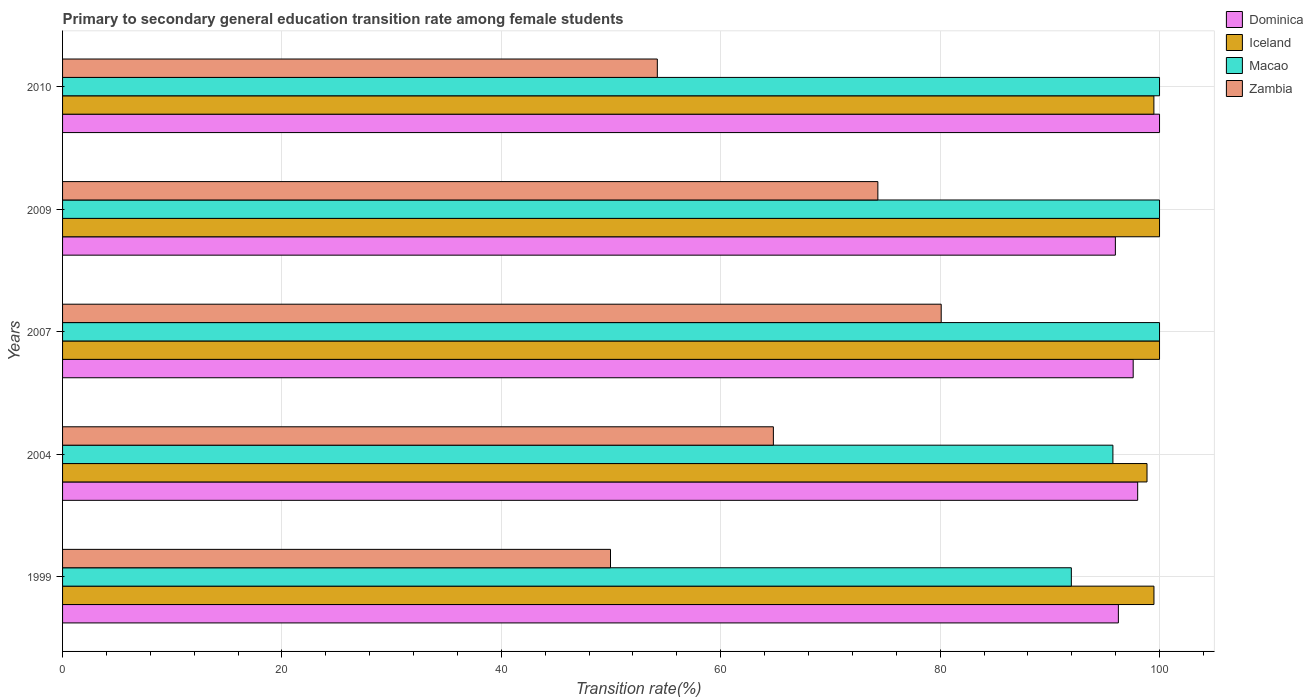Are the number of bars per tick equal to the number of legend labels?
Keep it short and to the point. Yes. Are the number of bars on each tick of the Y-axis equal?
Your answer should be compact. Yes. How many bars are there on the 5th tick from the bottom?
Provide a succinct answer. 4. What is the label of the 5th group of bars from the top?
Ensure brevity in your answer.  1999. In how many cases, is the number of bars for a given year not equal to the number of legend labels?
Ensure brevity in your answer.  0. Across all years, what is the maximum transition rate in Macao?
Offer a terse response. 100. Across all years, what is the minimum transition rate in Dominica?
Provide a succinct answer. 95.97. What is the total transition rate in Iceland in the graph?
Offer a very short reply. 497.83. What is the difference between the transition rate in Iceland in 1999 and that in 2010?
Give a very brief answer. 0.01. What is the difference between the transition rate in Dominica in 2010 and the transition rate in Macao in 1999?
Offer a very short reply. 8.04. What is the average transition rate in Zambia per year?
Make the answer very short. 64.68. What is the ratio of the transition rate in Iceland in 1999 to that in 2010?
Offer a very short reply. 1. Is the transition rate in Zambia in 1999 less than that in 2010?
Your answer should be very brief. Yes. What is the difference between the highest and the second highest transition rate in Zambia?
Your response must be concise. 5.77. What is the difference between the highest and the lowest transition rate in Macao?
Provide a short and direct response. 8.04. What does the 4th bar from the bottom in 2004 represents?
Offer a terse response. Zambia. How many bars are there?
Ensure brevity in your answer.  20. Are all the bars in the graph horizontal?
Your response must be concise. Yes. How many years are there in the graph?
Your answer should be compact. 5. What is the difference between two consecutive major ticks on the X-axis?
Your response must be concise. 20. Are the values on the major ticks of X-axis written in scientific E-notation?
Provide a succinct answer. No. Where does the legend appear in the graph?
Offer a terse response. Top right. What is the title of the graph?
Give a very brief answer. Primary to secondary general education transition rate among female students. Does "Kuwait" appear as one of the legend labels in the graph?
Make the answer very short. No. What is the label or title of the X-axis?
Provide a short and direct response. Transition rate(%). What is the label or title of the Y-axis?
Your answer should be compact. Years. What is the Transition rate(%) of Dominica in 1999?
Keep it short and to the point. 96.25. What is the Transition rate(%) in Iceland in 1999?
Offer a very short reply. 99.49. What is the Transition rate(%) in Macao in 1999?
Offer a very short reply. 91.96. What is the Transition rate(%) of Zambia in 1999?
Provide a succinct answer. 49.95. What is the Transition rate(%) in Dominica in 2004?
Your response must be concise. 98.01. What is the Transition rate(%) in Iceland in 2004?
Provide a succinct answer. 98.86. What is the Transition rate(%) in Macao in 2004?
Provide a succinct answer. 95.75. What is the Transition rate(%) of Zambia in 2004?
Offer a very short reply. 64.8. What is the Transition rate(%) of Dominica in 2007?
Give a very brief answer. 97.6. What is the Transition rate(%) of Iceland in 2007?
Offer a terse response. 100. What is the Transition rate(%) of Macao in 2007?
Make the answer very short. 100. What is the Transition rate(%) of Zambia in 2007?
Provide a succinct answer. 80.1. What is the Transition rate(%) in Dominica in 2009?
Make the answer very short. 95.97. What is the Transition rate(%) of Iceland in 2009?
Make the answer very short. 100. What is the Transition rate(%) in Macao in 2009?
Your answer should be compact. 100. What is the Transition rate(%) in Zambia in 2009?
Make the answer very short. 74.32. What is the Transition rate(%) of Dominica in 2010?
Offer a very short reply. 100. What is the Transition rate(%) in Iceland in 2010?
Keep it short and to the point. 99.49. What is the Transition rate(%) in Zambia in 2010?
Your response must be concise. 54.22. Across all years, what is the maximum Transition rate(%) of Dominica?
Provide a succinct answer. 100. Across all years, what is the maximum Transition rate(%) of Iceland?
Your answer should be compact. 100. Across all years, what is the maximum Transition rate(%) in Macao?
Your response must be concise. 100. Across all years, what is the maximum Transition rate(%) of Zambia?
Make the answer very short. 80.1. Across all years, what is the minimum Transition rate(%) in Dominica?
Offer a very short reply. 95.97. Across all years, what is the minimum Transition rate(%) in Iceland?
Provide a succinct answer. 98.86. Across all years, what is the minimum Transition rate(%) of Macao?
Provide a short and direct response. 91.96. Across all years, what is the minimum Transition rate(%) in Zambia?
Provide a succinct answer. 49.95. What is the total Transition rate(%) of Dominica in the graph?
Provide a short and direct response. 487.83. What is the total Transition rate(%) in Iceland in the graph?
Provide a short and direct response. 497.83. What is the total Transition rate(%) in Macao in the graph?
Your answer should be very brief. 487.71. What is the total Transition rate(%) in Zambia in the graph?
Your answer should be compact. 323.39. What is the difference between the Transition rate(%) of Dominica in 1999 and that in 2004?
Offer a terse response. -1.76. What is the difference between the Transition rate(%) of Iceland in 1999 and that in 2004?
Ensure brevity in your answer.  0.63. What is the difference between the Transition rate(%) of Macao in 1999 and that in 2004?
Offer a terse response. -3.79. What is the difference between the Transition rate(%) in Zambia in 1999 and that in 2004?
Make the answer very short. -14.85. What is the difference between the Transition rate(%) in Dominica in 1999 and that in 2007?
Provide a succinct answer. -1.35. What is the difference between the Transition rate(%) in Iceland in 1999 and that in 2007?
Your response must be concise. -0.51. What is the difference between the Transition rate(%) of Macao in 1999 and that in 2007?
Your answer should be very brief. -8.04. What is the difference between the Transition rate(%) in Zambia in 1999 and that in 2007?
Your response must be concise. -30.15. What is the difference between the Transition rate(%) of Dominica in 1999 and that in 2009?
Keep it short and to the point. 0.27. What is the difference between the Transition rate(%) of Iceland in 1999 and that in 2009?
Your answer should be very brief. -0.51. What is the difference between the Transition rate(%) of Macao in 1999 and that in 2009?
Offer a very short reply. -8.04. What is the difference between the Transition rate(%) of Zambia in 1999 and that in 2009?
Provide a short and direct response. -24.37. What is the difference between the Transition rate(%) in Dominica in 1999 and that in 2010?
Make the answer very short. -3.75. What is the difference between the Transition rate(%) in Iceland in 1999 and that in 2010?
Ensure brevity in your answer.  0.01. What is the difference between the Transition rate(%) of Macao in 1999 and that in 2010?
Provide a succinct answer. -8.04. What is the difference between the Transition rate(%) of Zambia in 1999 and that in 2010?
Your response must be concise. -4.27. What is the difference between the Transition rate(%) of Dominica in 2004 and that in 2007?
Provide a short and direct response. 0.41. What is the difference between the Transition rate(%) in Iceland in 2004 and that in 2007?
Make the answer very short. -1.14. What is the difference between the Transition rate(%) in Macao in 2004 and that in 2007?
Provide a succinct answer. -4.25. What is the difference between the Transition rate(%) of Zambia in 2004 and that in 2007?
Keep it short and to the point. -15.3. What is the difference between the Transition rate(%) of Dominica in 2004 and that in 2009?
Provide a short and direct response. 2.03. What is the difference between the Transition rate(%) of Iceland in 2004 and that in 2009?
Provide a succinct answer. -1.14. What is the difference between the Transition rate(%) in Macao in 2004 and that in 2009?
Offer a terse response. -4.25. What is the difference between the Transition rate(%) in Zambia in 2004 and that in 2009?
Keep it short and to the point. -9.52. What is the difference between the Transition rate(%) in Dominica in 2004 and that in 2010?
Offer a terse response. -1.99. What is the difference between the Transition rate(%) in Iceland in 2004 and that in 2010?
Your answer should be compact. -0.63. What is the difference between the Transition rate(%) of Macao in 2004 and that in 2010?
Provide a short and direct response. -4.25. What is the difference between the Transition rate(%) of Zambia in 2004 and that in 2010?
Provide a short and direct response. 10.58. What is the difference between the Transition rate(%) in Dominica in 2007 and that in 2009?
Give a very brief answer. 1.62. What is the difference between the Transition rate(%) in Zambia in 2007 and that in 2009?
Ensure brevity in your answer.  5.77. What is the difference between the Transition rate(%) in Dominica in 2007 and that in 2010?
Your answer should be compact. -2.4. What is the difference between the Transition rate(%) in Iceland in 2007 and that in 2010?
Ensure brevity in your answer.  0.51. What is the difference between the Transition rate(%) of Zambia in 2007 and that in 2010?
Offer a terse response. 25.88. What is the difference between the Transition rate(%) in Dominica in 2009 and that in 2010?
Make the answer very short. -4.03. What is the difference between the Transition rate(%) of Iceland in 2009 and that in 2010?
Provide a succinct answer. 0.51. What is the difference between the Transition rate(%) of Macao in 2009 and that in 2010?
Provide a succinct answer. 0. What is the difference between the Transition rate(%) of Zambia in 2009 and that in 2010?
Give a very brief answer. 20.1. What is the difference between the Transition rate(%) in Dominica in 1999 and the Transition rate(%) in Iceland in 2004?
Give a very brief answer. -2.61. What is the difference between the Transition rate(%) of Dominica in 1999 and the Transition rate(%) of Macao in 2004?
Your answer should be compact. 0.5. What is the difference between the Transition rate(%) of Dominica in 1999 and the Transition rate(%) of Zambia in 2004?
Your response must be concise. 31.45. What is the difference between the Transition rate(%) in Iceland in 1999 and the Transition rate(%) in Macao in 2004?
Provide a short and direct response. 3.74. What is the difference between the Transition rate(%) of Iceland in 1999 and the Transition rate(%) of Zambia in 2004?
Your answer should be compact. 34.69. What is the difference between the Transition rate(%) of Macao in 1999 and the Transition rate(%) of Zambia in 2004?
Offer a terse response. 27.16. What is the difference between the Transition rate(%) of Dominica in 1999 and the Transition rate(%) of Iceland in 2007?
Ensure brevity in your answer.  -3.75. What is the difference between the Transition rate(%) in Dominica in 1999 and the Transition rate(%) in Macao in 2007?
Provide a short and direct response. -3.75. What is the difference between the Transition rate(%) in Dominica in 1999 and the Transition rate(%) in Zambia in 2007?
Offer a very short reply. 16.15. What is the difference between the Transition rate(%) in Iceland in 1999 and the Transition rate(%) in Macao in 2007?
Give a very brief answer. -0.51. What is the difference between the Transition rate(%) of Iceland in 1999 and the Transition rate(%) of Zambia in 2007?
Offer a very short reply. 19.39. What is the difference between the Transition rate(%) in Macao in 1999 and the Transition rate(%) in Zambia in 2007?
Provide a succinct answer. 11.86. What is the difference between the Transition rate(%) in Dominica in 1999 and the Transition rate(%) in Iceland in 2009?
Keep it short and to the point. -3.75. What is the difference between the Transition rate(%) of Dominica in 1999 and the Transition rate(%) of Macao in 2009?
Make the answer very short. -3.75. What is the difference between the Transition rate(%) of Dominica in 1999 and the Transition rate(%) of Zambia in 2009?
Ensure brevity in your answer.  21.93. What is the difference between the Transition rate(%) in Iceland in 1999 and the Transition rate(%) in Macao in 2009?
Keep it short and to the point. -0.51. What is the difference between the Transition rate(%) of Iceland in 1999 and the Transition rate(%) of Zambia in 2009?
Provide a short and direct response. 25.17. What is the difference between the Transition rate(%) of Macao in 1999 and the Transition rate(%) of Zambia in 2009?
Offer a very short reply. 17.64. What is the difference between the Transition rate(%) of Dominica in 1999 and the Transition rate(%) of Iceland in 2010?
Keep it short and to the point. -3.24. What is the difference between the Transition rate(%) of Dominica in 1999 and the Transition rate(%) of Macao in 2010?
Offer a terse response. -3.75. What is the difference between the Transition rate(%) in Dominica in 1999 and the Transition rate(%) in Zambia in 2010?
Keep it short and to the point. 42.03. What is the difference between the Transition rate(%) in Iceland in 1999 and the Transition rate(%) in Macao in 2010?
Keep it short and to the point. -0.51. What is the difference between the Transition rate(%) of Iceland in 1999 and the Transition rate(%) of Zambia in 2010?
Give a very brief answer. 45.27. What is the difference between the Transition rate(%) in Macao in 1999 and the Transition rate(%) in Zambia in 2010?
Your response must be concise. 37.74. What is the difference between the Transition rate(%) of Dominica in 2004 and the Transition rate(%) of Iceland in 2007?
Provide a succinct answer. -1.99. What is the difference between the Transition rate(%) of Dominica in 2004 and the Transition rate(%) of Macao in 2007?
Provide a succinct answer. -1.99. What is the difference between the Transition rate(%) of Dominica in 2004 and the Transition rate(%) of Zambia in 2007?
Your answer should be compact. 17.91. What is the difference between the Transition rate(%) in Iceland in 2004 and the Transition rate(%) in Macao in 2007?
Ensure brevity in your answer.  -1.14. What is the difference between the Transition rate(%) of Iceland in 2004 and the Transition rate(%) of Zambia in 2007?
Your answer should be very brief. 18.76. What is the difference between the Transition rate(%) in Macao in 2004 and the Transition rate(%) in Zambia in 2007?
Your response must be concise. 15.65. What is the difference between the Transition rate(%) of Dominica in 2004 and the Transition rate(%) of Iceland in 2009?
Give a very brief answer. -1.99. What is the difference between the Transition rate(%) of Dominica in 2004 and the Transition rate(%) of Macao in 2009?
Provide a succinct answer. -1.99. What is the difference between the Transition rate(%) in Dominica in 2004 and the Transition rate(%) in Zambia in 2009?
Your answer should be very brief. 23.69. What is the difference between the Transition rate(%) of Iceland in 2004 and the Transition rate(%) of Macao in 2009?
Offer a terse response. -1.14. What is the difference between the Transition rate(%) in Iceland in 2004 and the Transition rate(%) in Zambia in 2009?
Provide a succinct answer. 24.54. What is the difference between the Transition rate(%) of Macao in 2004 and the Transition rate(%) of Zambia in 2009?
Offer a terse response. 21.43. What is the difference between the Transition rate(%) of Dominica in 2004 and the Transition rate(%) of Iceland in 2010?
Provide a short and direct response. -1.48. What is the difference between the Transition rate(%) in Dominica in 2004 and the Transition rate(%) in Macao in 2010?
Your response must be concise. -1.99. What is the difference between the Transition rate(%) in Dominica in 2004 and the Transition rate(%) in Zambia in 2010?
Your response must be concise. 43.79. What is the difference between the Transition rate(%) of Iceland in 2004 and the Transition rate(%) of Macao in 2010?
Make the answer very short. -1.14. What is the difference between the Transition rate(%) in Iceland in 2004 and the Transition rate(%) in Zambia in 2010?
Your answer should be very brief. 44.64. What is the difference between the Transition rate(%) in Macao in 2004 and the Transition rate(%) in Zambia in 2010?
Give a very brief answer. 41.53. What is the difference between the Transition rate(%) of Dominica in 2007 and the Transition rate(%) of Iceland in 2009?
Ensure brevity in your answer.  -2.4. What is the difference between the Transition rate(%) in Dominica in 2007 and the Transition rate(%) in Macao in 2009?
Provide a short and direct response. -2.4. What is the difference between the Transition rate(%) of Dominica in 2007 and the Transition rate(%) of Zambia in 2009?
Offer a terse response. 23.28. What is the difference between the Transition rate(%) of Iceland in 2007 and the Transition rate(%) of Zambia in 2009?
Your answer should be compact. 25.68. What is the difference between the Transition rate(%) in Macao in 2007 and the Transition rate(%) in Zambia in 2009?
Your answer should be compact. 25.68. What is the difference between the Transition rate(%) in Dominica in 2007 and the Transition rate(%) in Iceland in 2010?
Your answer should be very brief. -1.89. What is the difference between the Transition rate(%) of Dominica in 2007 and the Transition rate(%) of Macao in 2010?
Provide a short and direct response. -2.4. What is the difference between the Transition rate(%) of Dominica in 2007 and the Transition rate(%) of Zambia in 2010?
Offer a very short reply. 43.38. What is the difference between the Transition rate(%) of Iceland in 2007 and the Transition rate(%) of Macao in 2010?
Keep it short and to the point. 0. What is the difference between the Transition rate(%) in Iceland in 2007 and the Transition rate(%) in Zambia in 2010?
Provide a succinct answer. 45.78. What is the difference between the Transition rate(%) of Macao in 2007 and the Transition rate(%) of Zambia in 2010?
Your response must be concise. 45.78. What is the difference between the Transition rate(%) in Dominica in 2009 and the Transition rate(%) in Iceland in 2010?
Offer a very short reply. -3.51. What is the difference between the Transition rate(%) of Dominica in 2009 and the Transition rate(%) of Macao in 2010?
Provide a short and direct response. -4.03. What is the difference between the Transition rate(%) in Dominica in 2009 and the Transition rate(%) in Zambia in 2010?
Keep it short and to the point. 41.76. What is the difference between the Transition rate(%) of Iceland in 2009 and the Transition rate(%) of Zambia in 2010?
Keep it short and to the point. 45.78. What is the difference between the Transition rate(%) in Macao in 2009 and the Transition rate(%) in Zambia in 2010?
Provide a succinct answer. 45.78. What is the average Transition rate(%) of Dominica per year?
Offer a terse response. 97.57. What is the average Transition rate(%) in Iceland per year?
Offer a very short reply. 99.57. What is the average Transition rate(%) of Macao per year?
Your response must be concise. 97.54. What is the average Transition rate(%) in Zambia per year?
Your answer should be very brief. 64.68. In the year 1999, what is the difference between the Transition rate(%) in Dominica and Transition rate(%) in Iceland?
Your answer should be very brief. -3.24. In the year 1999, what is the difference between the Transition rate(%) in Dominica and Transition rate(%) in Macao?
Offer a terse response. 4.29. In the year 1999, what is the difference between the Transition rate(%) of Dominica and Transition rate(%) of Zambia?
Offer a very short reply. 46.3. In the year 1999, what is the difference between the Transition rate(%) in Iceland and Transition rate(%) in Macao?
Make the answer very short. 7.53. In the year 1999, what is the difference between the Transition rate(%) in Iceland and Transition rate(%) in Zambia?
Ensure brevity in your answer.  49.54. In the year 1999, what is the difference between the Transition rate(%) of Macao and Transition rate(%) of Zambia?
Make the answer very short. 42.01. In the year 2004, what is the difference between the Transition rate(%) of Dominica and Transition rate(%) of Iceland?
Give a very brief answer. -0.85. In the year 2004, what is the difference between the Transition rate(%) of Dominica and Transition rate(%) of Macao?
Give a very brief answer. 2.26. In the year 2004, what is the difference between the Transition rate(%) of Dominica and Transition rate(%) of Zambia?
Your answer should be very brief. 33.21. In the year 2004, what is the difference between the Transition rate(%) of Iceland and Transition rate(%) of Macao?
Make the answer very short. 3.11. In the year 2004, what is the difference between the Transition rate(%) in Iceland and Transition rate(%) in Zambia?
Keep it short and to the point. 34.06. In the year 2004, what is the difference between the Transition rate(%) of Macao and Transition rate(%) of Zambia?
Provide a short and direct response. 30.95. In the year 2007, what is the difference between the Transition rate(%) of Dominica and Transition rate(%) of Iceland?
Provide a short and direct response. -2.4. In the year 2007, what is the difference between the Transition rate(%) in Dominica and Transition rate(%) in Macao?
Give a very brief answer. -2.4. In the year 2007, what is the difference between the Transition rate(%) of Dominica and Transition rate(%) of Zambia?
Provide a short and direct response. 17.5. In the year 2007, what is the difference between the Transition rate(%) of Iceland and Transition rate(%) of Zambia?
Offer a very short reply. 19.9. In the year 2007, what is the difference between the Transition rate(%) in Macao and Transition rate(%) in Zambia?
Provide a succinct answer. 19.9. In the year 2009, what is the difference between the Transition rate(%) in Dominica and Transition rate(%) in Iceland?
Offer a very short reply. -4.03. In the year 2009, what is the difference between the Transition rate(%) in Dominica and Transition rate(%) in Macao?
Your response must be concise. -4.03. In the year 2009, what is the difference between the Transition rate(%) in Dominica and Transition rate(%) in Zambia?
Offer a terse response. 21.65. In the year 2009, what is the difference between the Transition rate(%) in Iceland and Transition rate(%) in Macao?
Your answer should be very brief. 0. In the year 2009, what is the difference between the Transition rate(%) in Iceland and Transition rate(%) in Zambia?
Offer a very short reply. 25.68. In the year 2009, what is the difference between the Transition rate(%) in Macao and Transition rate(%) in Zambia?
Offer a very short reply. 25.68. In the year 2010, what is the difference between the Transition rate(%) of Dominica and Transition rate(%) of Iceland?
Offer a terse response. 0.51. In the year 2010, what is the difference between the Transition rate(%) in Dominica and Transition rate(%) in Zambia?
Your answer should be very brief. 45.78. In the year 2010, what is the difference between the Transition rate(%) of Iceland and Transition rate(%) of Macao?
Ensure brevity in your answer.  -0.51. In the year 2010, what is the difference between the Transition rate(%) of Iceland and Transition rate(%) of Zambia?
Your response must be concise. 45.27. In the year 2010, what is the difference between the Transition rate(%) in Macao and Transition rate(%) in Zambia?
Your answer should be very brief. 45.78. What is the ratio of the Transition rate(%) in Iceland in 1999 to that in 2004?
Keep it short and to the point. 1.01. What is the ratio of the Transition rate(%) in Macao in 1999 to that in 2004?
Provide a succinct answer. 0.96. What is the ratio of the Transition rate(%) of Zambia in 1999 to that in 2004?
Ensure brevity in your answer.  0.77. What is the ratio of the Transition rate(%) of Dominica in 1999 to that in 2007?
Offer a terse response. 0.99. What is the ratio of the Transition rate(%) of Iceland in 1999 to that in 2007?
Offer a terse response. 0.99. What is the ratio of the Transition rate(%) in Macao in 1999 to that in 2007?
Keep it short and to the point. 0.92. What is the ratio of the Transition rate(%) of Zambia in 1999 to that in 2007?
Your response must be concise. 0.62. What is the ratio of the Transition rate(%) of Dominica in 1999 to that in 2009?
Offer a very short reply. 1. What is the ratio of the Transition rate(%) in Iceland in 1999 to that in 2009?
Make the answer very short. 0.99. What is the ratio of the Transition rate(%) of Macao in 1999 to that in 2009?
Your response must be concise. 0.92. What is the ratio of the Transition rate(%) in Zambia in 1999 to that in 2009?
Make the answer very short. 0.67. What is the ratio of the Transition rate(%) in Dominica in 1999 to that in 2010?
Keep it short and to the point. 0.96. What is the ratio of the Transition rate(%) in Macao in 1999 to that in 2010?
Keep it short and to the point. 0.92. What is the ratio of the Transition rate(%) in Zambia in 1999 to that in 2010?
Give a very brief answer. 0.92. What is the ratio of the Transition rate(%) of Dominica in 2004 to that in 2007?
Keep it short and to the point. 1. What is the ratio of the Transition rate(%) in Iceland in 2004 to that in 2007?
Make the answer very short. 0.99. What is the ratio of the Transition rate(%) of Macao in 2004 to that in 2007?
Your answer should be compact. 0.96. What is the ratio of the Transition rate(%) of Zambia in 2004 to that in 2007?
Make the answer very short. 0.81. What is the ratio of the Transition rate(%) in Dominica in 2004 to that in 2009?
Your answer should be very brief. 1.02. What is the ratio of the Transition rate(%) in Iceland in 2004 to that in 2009?
Your answer should be very brief. 0.99. What is the ratio of the Transition rate(%) of Macao in 2004 to that in 2009?
Keep it short and to the point. 0.96. What is the ratio of the Transition rate(%) in Zambia in 2004 to that in 2009?
Offer a very short reply. 0.87. What is the ratio of the Transition rate(%) of Dominica in 2004 to that in 2010?
Make the answer very short. 0.98. What is the ratio of the Transition rate(%) of Macao in 2004 to that in 2010?
Ensure brevity in your answer.  0.96. What is the ratio of the Transition rate(%) in Zambia in 2004 to that in 2010?
Provide a succinct answer. 1.2. What is the ratio of the Transition rate(%) of Dominica in 2007 to that in 2009?
Offer a very short reply. 1.02. What is the ratio of the Transition rate(%) in Macao in 2007 to that in 2009?
Make the answer very short. 1. What is the ratio of the Transition rate(%) in Zambia in 2007 to that in 2009?
Give a very brief answer. 1.08. What is the ratio of the Transition rate(%) in Macao in 2007 to that in 2010?
Your response must be concise. 1. What is the ratio of the Transition rate(%) of Zambia in 2007 to that in 2010?
Ensure brevity in your answer.  1.48. What is the ratio of the Transition rate(%) in Dominica in 2009 to that in 2010?
Ensure brevity in your answer.  0.96. What is the ratio of the Transition rate(%) of Macao in 2009 to that in 2010?
Make the answer very short. 1. What is the ratio of the Transition rate(%) in Zambia in 2009 to that in 2010?
Provide a succinct answer. 1.37. What is the difference between the highest and the second highest Transition rate(%) in Dominica?
Provide a short and direct response. 1.99. What is the difference between the highest and the second highest Transition rate(%) of Iceland?
Give a very brief answer. 0. What is the difference between the highest and the second highest Transition rate(%) of Zambia?
Give a very brief answer. 5.77. What is the difference between the highest and the lowest Transition rate(%) in Dominica?
Provide a succinct answer. 4.03. What is the difference between the highest and the lowest Transition rate(%) of Iceland?
Offer a very short reply. 1.14. What is the difference between the highest and the lowest Transition rate(%) in Macao?
Your answer should be compact. 8.04. What is the difference between the highest and the lowest Transition rate(%) in Zambia?
Your response must be concise. 30.15. 